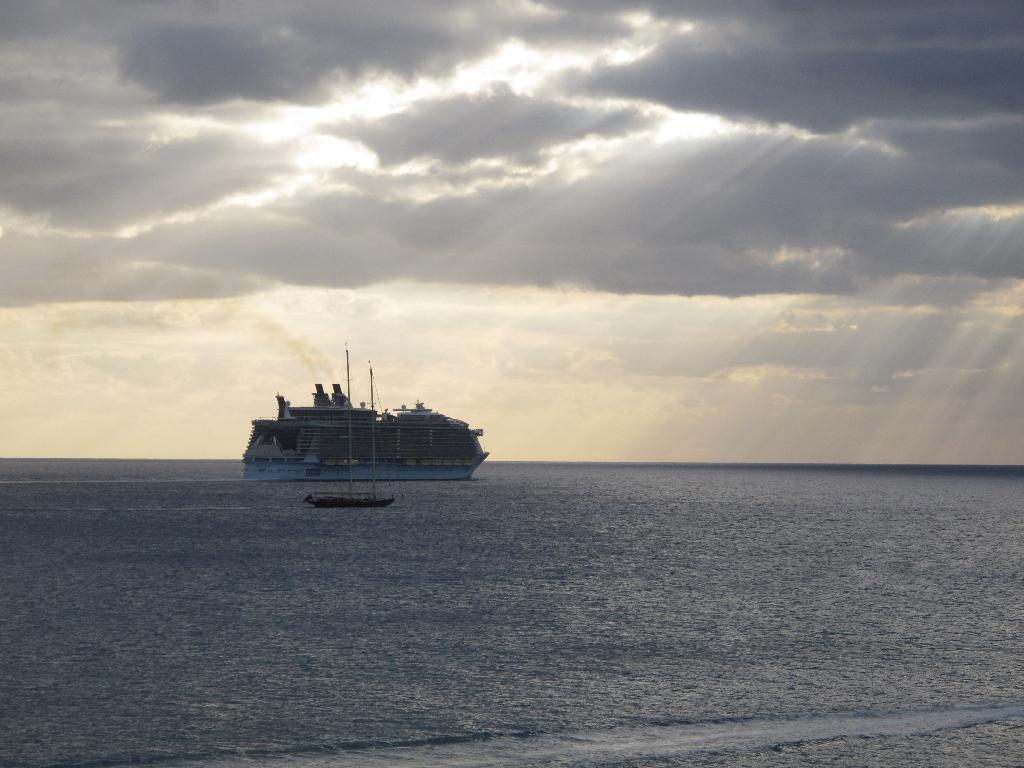What type of watercraft can be seen in the image? There is a ship and a boat in the image. What are the watercraft doing in the image? Both the ship and boat are sailing on the surface of the water. What is visible at the top of the image? The sky is visible at the top of the image. What can be observed in the sky? There are clouds in the sky. What type of science experiment is being conducted on the ship in the image? There is no indication of a science experiment being conducted on the ship in the image. How many eggs are visible on the boat in the image? There are no eggs present in the image. 